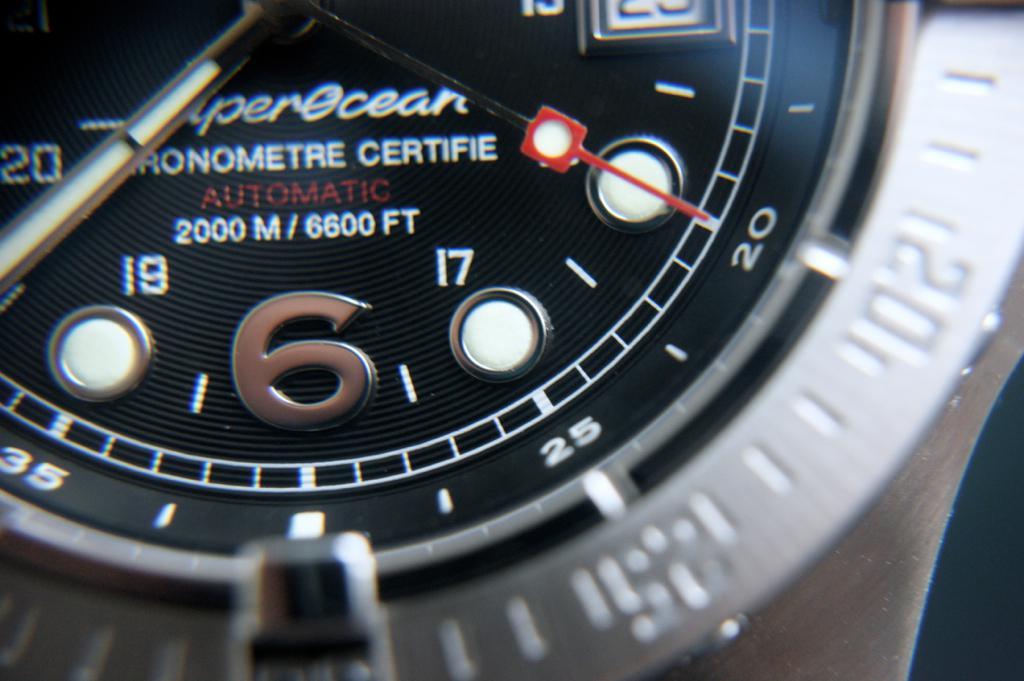What is this watch certified for?
Offer a very short reply. Chronometre. What is the large silver number?
Your answer should be very brief. 6. 